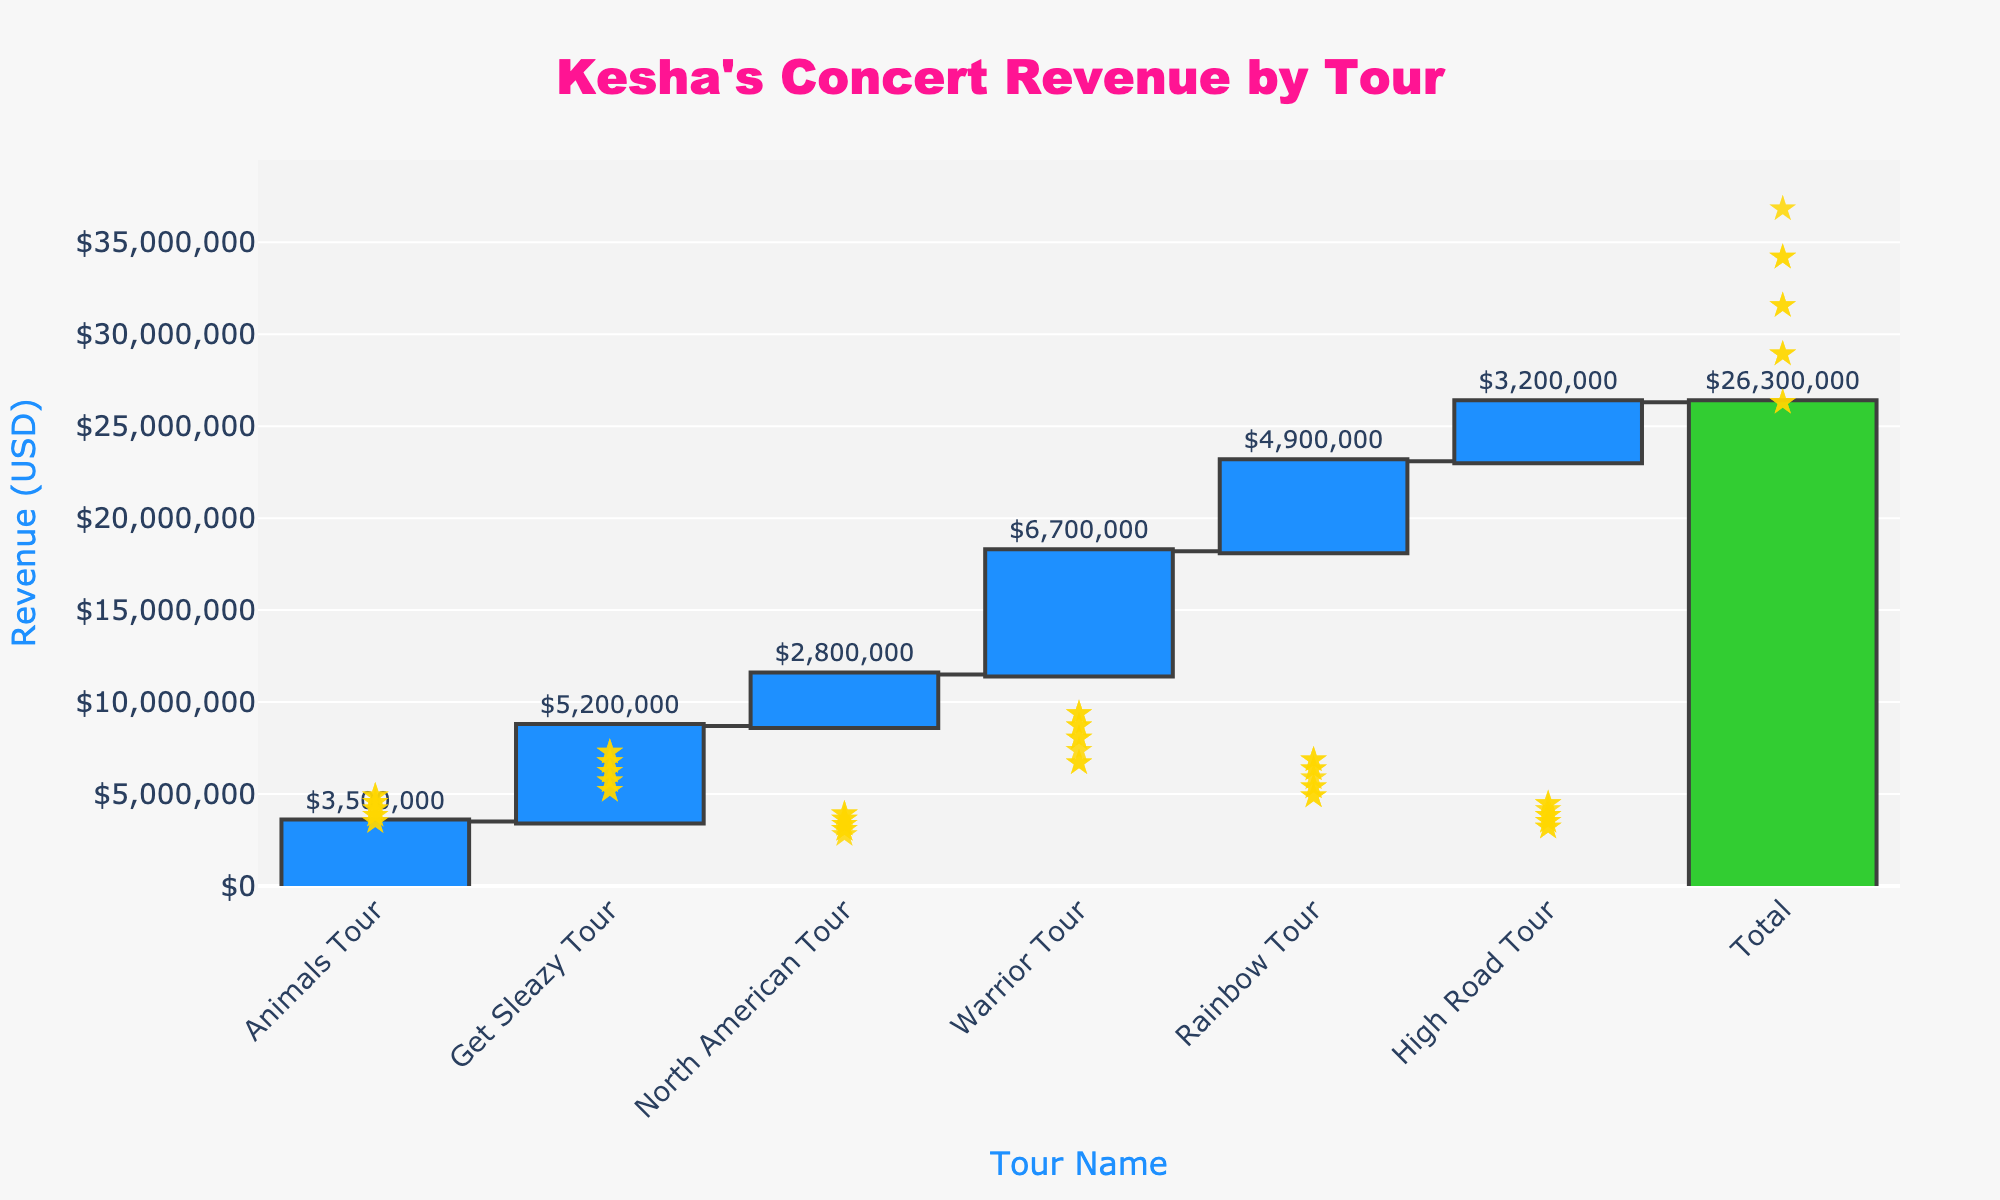what is the title of the figure? The title of the figure is typically shown at the top of the chart. In this case, the title is written in a larger and distinct font to make it easily identifiable.
Answer: Kesha's Concert Revenue by Tour what is the highest revenue tour and what is its value? To find the highest revenue tour, look for the bar that extends the highest in the positive direction. The label associated with this bar indicates the highest revenue tour. The value is displayed near the corresponding bar.
Answer: Warrior Tour, $6,700,000 how much more revenue did the Get Sleazy Tour generate than the High Road Tour? Subtract the revenue of the High Road Tour from the revenue of the Get Sleazy Tour: $5,200,000 - $3,200,000.
Answer: $2,000,000 what is the cumulative revenue after the Rainbow Tour? To find the cumulative revenue after the Rainbow Tour, look at the total of all previous tour revenues and sum them up: $3,500,000 + $5,200,000 + $2,800,000 + $6,700,000 + $4,900,000. Explain the logic step-by-step considering each tour contribution.
Answer: $23,100,000 which tour had the lowest revenue and its value? The lowest revenue tour can be identified by finding the shortest bar among the tour-specific bars. The associated label and value will indicate the lowest revenue tour.
Answer: High Road Tour, $3,200,000 what is the total revenue generated from all Kesha tours combined? The total revenue is provided as the final cumulative value on the chart, typically highlighted. This is the sum of all individual tour revenues.
Answer: $26,300,000 compare the revenue generated by the North American Tour and the High Road Tour. Which one generated more and by how much? Compare the revenue values associated with the North American Tour and the High Road Tour. Subtract the lower value from the higher value to find the difference: $2,800,000 (North American Tour) vs $3,200,000 (High Road Tour).
Answer: High Road Tour, $400,000 more what is the average revenue generated per tour (excluding the total)? To calculate the average revenue per tour, sum the revenue values of all tours and divide by the number of tours. Sum = $3,500,000 + $5,200,000 + $2,800,000 + $6,700,000 + $4,900,000 + $3,200,000; Number of tours = 6. Average = Sum/Number of tours.
Answer: $4,383,333 how much revenue was generated by Kesha before the Warrior Tour? Add up only the revenues of the tours occurring before the Warrior Tour: $3,500,000 (Animals Tour) + $5,200,000 (Get Sleazy Tour) + $2,800,000 (North American Tour). Sum these values to find the cumulative revenue before the Warrior Tour.
Answer: $11,500,000 